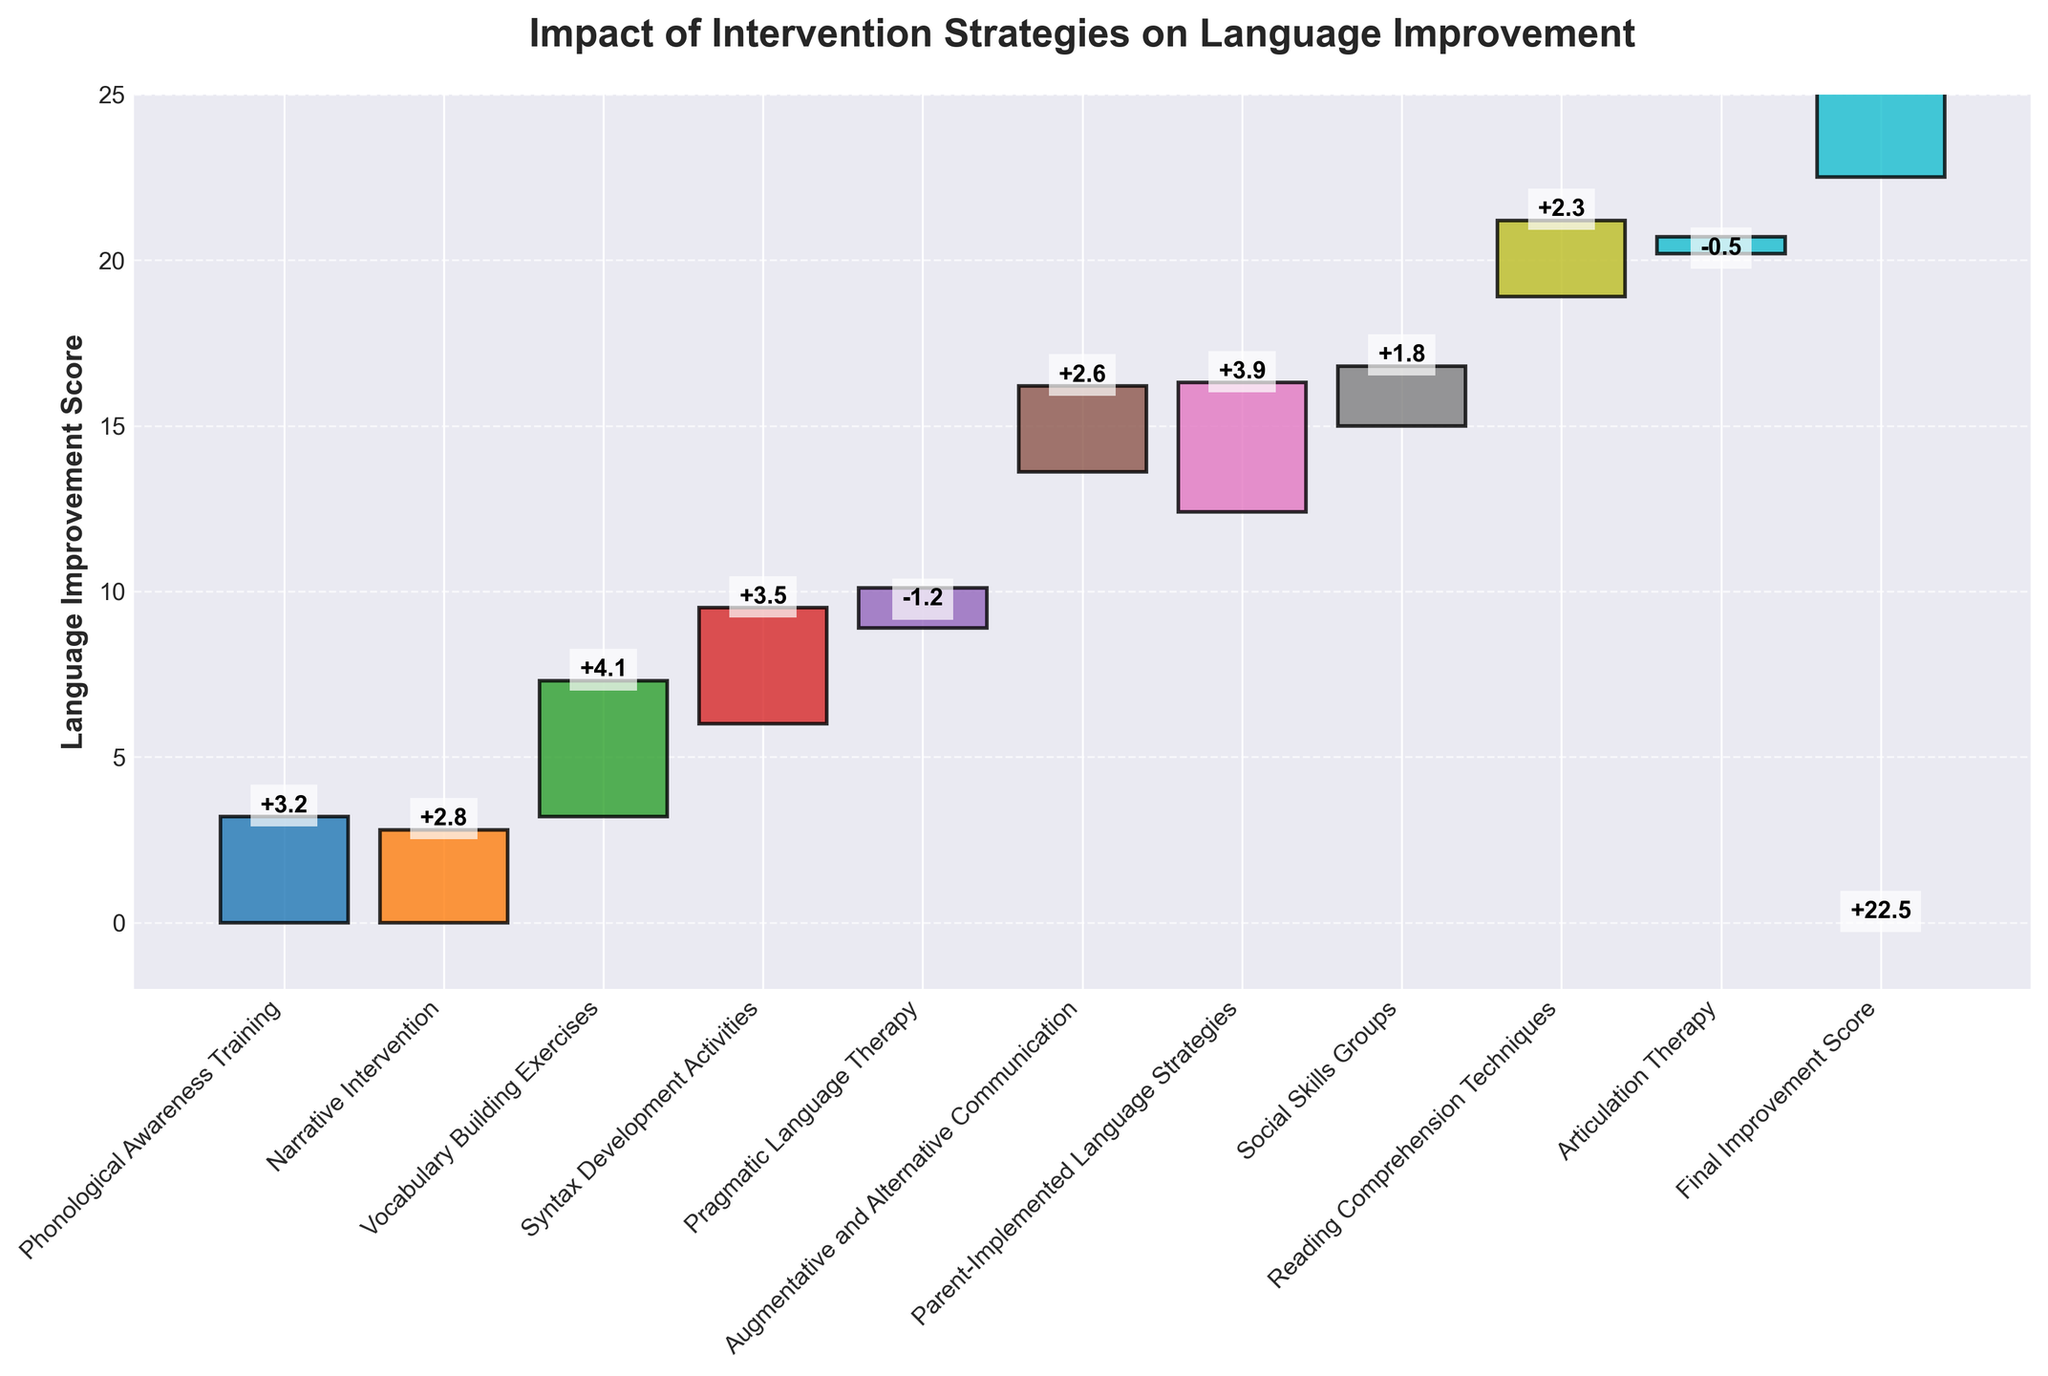What's the final improvement score? The final improvement score is shown at the end of the waterfall chart labeled "Final Improvement Score." It is the cumulative result of all interventions.
Answer: 22.5 Which intervention had the largest positive impact on the language improvement score? By analyzing the heights of the bars in the waterfall chart, the "Vocabulary Building Exercises" intervention has the tallest bar, indicating the largest positive impact.
Answer: Vocabulary Building Exercises Which intervention had a negative impact on the language improvement score? There are two interventions with negative impact shown by downward bars in the waterfall chart: "Pragmatic Language Therapy" and "Articulation Therapy."
Answer: Pragmatic Language Therapy and Articulation Therapy What is the cumulative score before the final bar? The cumulative score before the final bar represents the total improvement score after all individual interventions but before the final cumulative calculation, appearing just before the "Final Improvement Score" bar.
Answer: 22.5 Add together the scores from "Phonological Awareness Training" and "Narrative Intervention." What is the result? The score for "Phonological Awareness Training" is 3.2 and for "Narrative Intervention" is 2.8. Adding them together results in 3.2 + 2.8 = 6.0.
Answer: 6.0 Which intervention contributed similarly to "Social Skills Groups" in terms of impact? By comparing the heights of the bars, "Reading Comprehension Techniques" had a similar impact to "Social Skills Groups" as both have relatively close values.
Answer: Reading Comprehension Techniques What are the colors used for "Syntax Development Activities" and "Articulation Therapy"? The bar for "Syntax Development Activities" is green, and the bar for "Articulation Therapy" is a lighter blue shade.
Answer: Green and Light Blue How many interventions resulted in a decrease in score? By counting the bars that go downward in the waterfall chart, there are two interventions that resulted in a decrease in score, indicated by negative values.
Answer: 2 What is the combined impact of all interventions with negative scores? The negative scores are -1.2 (Pragmatic Language Therapy) and -0.5 (Articulation Therapy). Summing these values gives -1.2 + (-0.5) = -1.7.
Answer: -1.7 